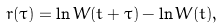Convert formula to latex. <formula><loc_0><loc_0><loc_500><loc_500>r ( \tau ) = \ln W ( t + \tau ) - \ln W ( t ) ,</formula> 